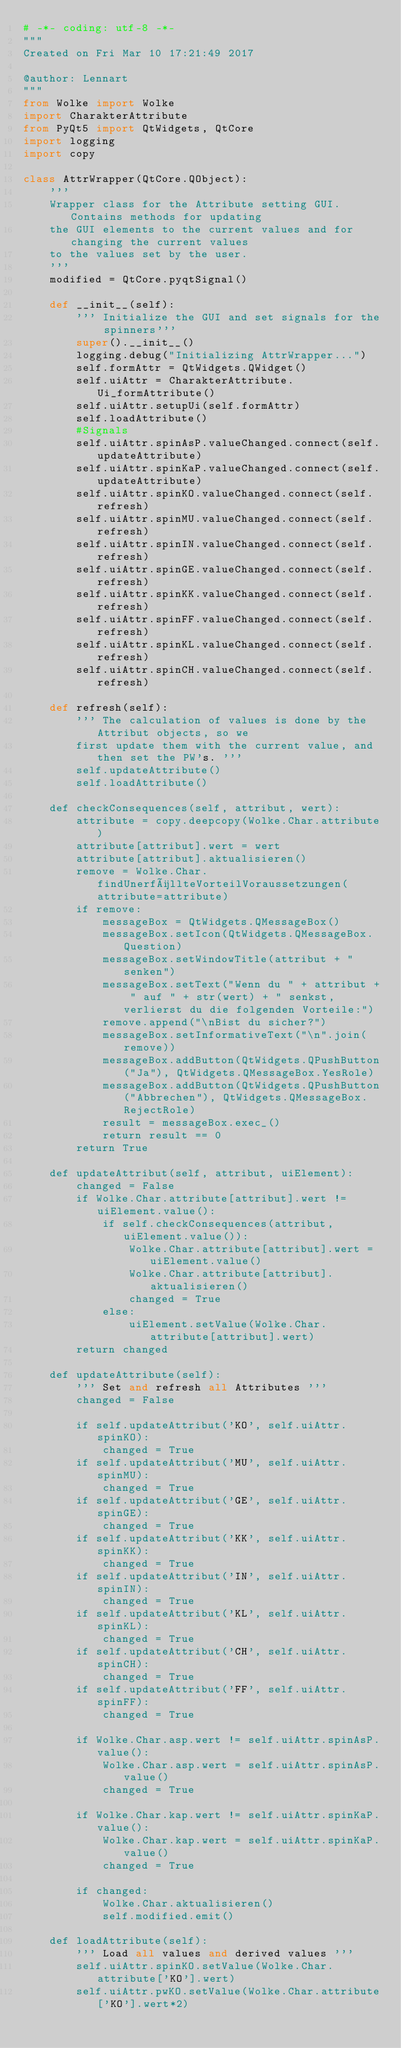Convert code to text. <code><loc_0><loc_0><loc_500><loc_500><_Python_># -*- coding: utf-8 -*-
"""
Created on Fri Mar 10 17:21:49 2017

@author: Lennart
"""
from Wolke import Wolke
import CharakterAttribute
from PyQt5 import QtWidgets, QtCore
import logging
import copy

class AttrWrapper(QtCore.QObject):
    ''' 
    Wrapper class for the Attribute setting GUI. Contains methods for updating
    the GUI elements to the current values and for changing the current values
    to the values set by the user. 
    '''
    modified = QtCore.pyqtSignal()
    
    def __init__(self):
        ''' Initialize the GUI and set signals for the spinners'''
        super().__init__()
        logging.debug("Initializing AttrWrapper...")
        self.formAttr = QtWidgets.QWidget()
        self.uiAttr = CharakterAttribute.Ui_formAttribute()
        self.uiAttr.setupUi(self.formAttr)
        self.loadAttribute()
        #Signals
        self.uiAttr.spinAsP.valueChanged.connect(self.updateAttribute)
        self.uiAttr.spinKaP.valueChanged.connect(self.updateAttribute)
        self.uiAttr.spinKO.valueChanged.connect(self.refresh)
        self.uiAttr.spinMU.valueChanged.connect(self.refresh)
        self.uiAttr.spinIN.valueChanged.connect(self.refresh)
        self.uiAttr.spinGE.valueChanged.connect(self.refresh)
        self.uiAttr.spinKK.valueChanged.connect(self.refresh)
        self.uiAttr.spinFF.valueChanged.connect(self.refresh)
        self.uiAttr.spinKL.valueChanged.connect(self.refresh)
        self.uiAttr.spinCH.valueChanged.connect(self.refresh)
        
    def refresh(self):
        ''' The calculation of values is done by the Attribut objects, so we 
        first update them with the current value, and then set the PW's. '''
        self.updateAttribute()
        self.loadAttribute()
     
    def checkConsequences(self, attribut, wert):
        attribute = copy.deepcopy(Wolke.Char.attribute)
        attribute[attribut].wert = wert
        attribute[attribut].aktualisieren()
        remove = Wolke.Char.findUnerfüllteVorteilVoraussetzungen(attribute=attribute)
        if remove:
            messageBox = QtWidgets.QMessageBox()
            messageBox.setIcon(QtWidgets.QMessageBox.Question)
            messageBox.setWindowTitle(attribut + " senken")
            messageBox.setText("Wenn du " + attribut + " auf " + str(wert) + " senkst, verlierst du die folgenden Vorteile:")
            remove.append("\nBist du sicher?")
            messageBox.setInformativeText("\n".join(remove))
            messageBox.addButton(QtWidgets.QPushButton("Ja"), QtWidgets.QMessageBox.YesRole)
            messageBox.addButton(QtWidgets.QPushButton("Abbrechen"), QtWidgets.QMessageBox.RejectRole)
            result = messageBox.exec_()
            return result == 0
        return True

    def updateAttribut(self, attribut, uiElement):
        changed = False
        if Wolke.Char.attribute[attribut].wert != uiElement.value():
            if self.checkConsequences(attribut, uiElement.value()):
                Wolke.Char.attribute[attribut].wert = uiElement.value()
                Wolke.Char.attribute[attribut].aktualisieren()
                changed = True
            else:
                uiElement.setValue(Wolke.Char.attribute[attribut].wert)
        return changed

    def updateAttribute(self):
        ''' Set and refresh all Attributes '''
        changed = False

        if self.updateAttribut('KO', self.uiAttr.spinKO):
            changed = True
        if self.updateAttribut('MU', self.uiAttr.spinMU):
            changed = True
        if self.updateAttribut('GE', self.uiAttr.spinGE):
            changed = True
        if self.updateAttribut('KK', self.uiAttr.spinKK):
            changed = True
        if self.updateAttribut('IN', self.uiAttr.spinIN):
            changed = True
        if self.updateAttribut('KL', self.uiAttr.spinKL):
            changed = True
        if self.updateAttribut('CH', self.uiAttr.spinCH):
            changed = True
        if self.updateAttribut('FF', self.uiAttr.spinFF):
            changed = True

        if Wolke.Char.asp.wert != self.uiAttr.spinAsP.value():
            Wolke.Char.asp.wert = self.uiAttr.spinAsP.value()
            changed = True

        if Wolke.Char.kap.wert != self.uiAttr.spinKaP.value():
            Wolke.Char.kap.wert = self.uiAttr.spinKaP.value()
            changed = True

        if changed:
            Wolke.Char.aktualisieren()
            self.modified.emit()
        
    def loadAttribute(self):
        ''' Load all values and derived values '''
        self.uiAttr.spinKO.setValue(Wolke.Char.attribute['KO'].wert)
        self.uiAttr.pwKO.setValue(Wolke.Char.attribute['KO'].wert*2)</code> 